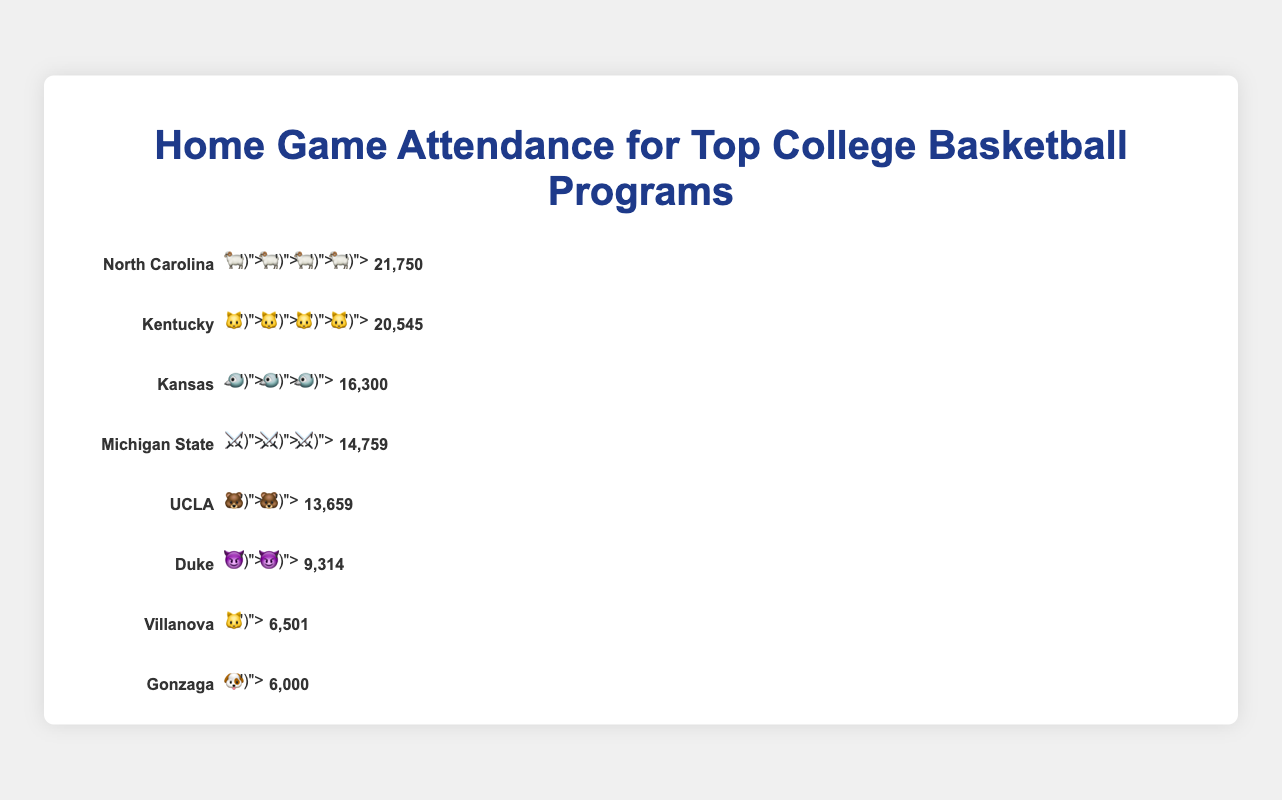How many college basketball programs are shown in the figure? The figure displays a separate row for each program with attendance data. Count the number of rows to determine the number of programs.
Answer: 8 Which program has the highest home game attendance? Look for the program with the longest attendance bar and check the corresponding attendance value. North Carolina has the longest bar, indicating the highest attendance.
Answer: North Carolina What is the sum of home game attendances for Duke, Villanova, and Gonzaga? Check the attendance values for Duke (9,314), Villanova (6,501), and Gonzaga (6,000). Sum these values: 9,314 + 6,501 + 6,000.
Answer: 21,815 Which program has the icon represented by a wildcat and what is their attendance? Identify the programs with wildcat icons and their corresponding attendance values. Villanova (6,501) and Kentucky (20,545) have wildcat icons. The question is about a program with "a wildcat", so either can be the answer.
Answer: Kentucky (20,545) or Villanova (6,501) How much higher is Kentucky's attendance compared to UCLA's? Check the attendance values for Kentucky and UCLA. Subtract UCLA's attendance from Kentucky's attendance: 20,545 - 13,659.
Answer: 6,886 What is the average attendance among all the programs? Sum the attendance values for all programs and divide by the number of programs: (9314 + 20545 + 21750 + 16300 + 14759 + 6000 + 13659 + 6501) / 8.
Answer: 13,854 Which program has the lowest home game attendance? Look for the program with the shortest attendance bar and check the corresponding attendance value. Gonzaga has the shortest bar.
Answer: Gonzaga How many programs have an attendance higher than 15,000? Identify the programs with attendance values greater than 15,000. Count these programs: Kentucky, North Carolina, and Kansas.
Answer: 3 What is the difference in attendance between the program with the second-highest attendance and the lowest attendance? The program with the second-highest attendance is Kentucky (20,545) and the lowest is Gonzaga (6,000). Subtract Gonzaga's attendance from Kentucky's attendance: 20,545 - 6,000.
Answer: 14,545 